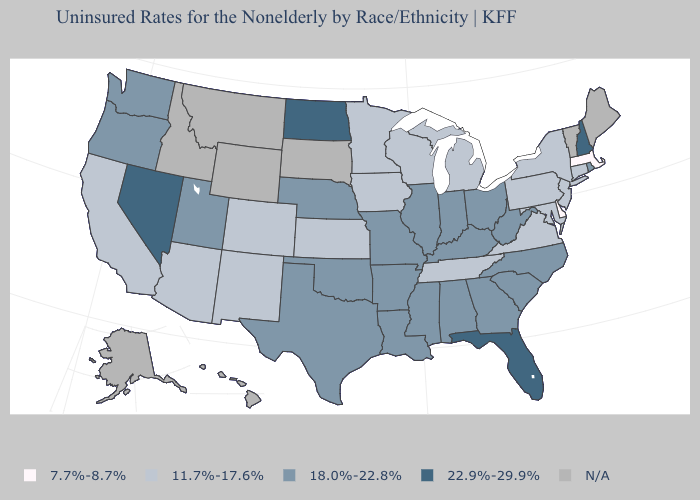Name the states that have a value in the range N/A?
Concise answer only. Alaska, Hawaii, Idaho, Maine, Montana, South Dakota, Vermont, Wyoming. Name the states that have a value in the range N/A?
Concise answer only. Alaska, Hawaii, Idaho, Maine, Montana, South Dakota, Vermont, Wyoming. What is the lowest value in the USA?
Be succinct. 7.7%-8.7%. What is the value of Louisiana?
Concise answer only. 18.0%-22.8%. Is the legend a continuous bar?
Write a very short answer. No. How many symbols are there in the legend?
Short answer required. 5. What is the value of Montana?
Keep it brief. N/A. Which states have the lowest value in the USA?
Keep it brief. Delaware, Massachusetts. Name the states that have a value in the range N/A?
Write a very short answer. Alaska, Hawaii, Idaho, Maine, Montana, South Dakota, Vermont, Wyoming. What is the value of Alaska?
Be succinct. N/A. Does Florida have the highest value in the South?
Short answer required. Yes. What is the value of California?
Keep it brief. 11.7%-17.6%. Does Nebraska have the lowest value in the USA?
Short answer required. No. 